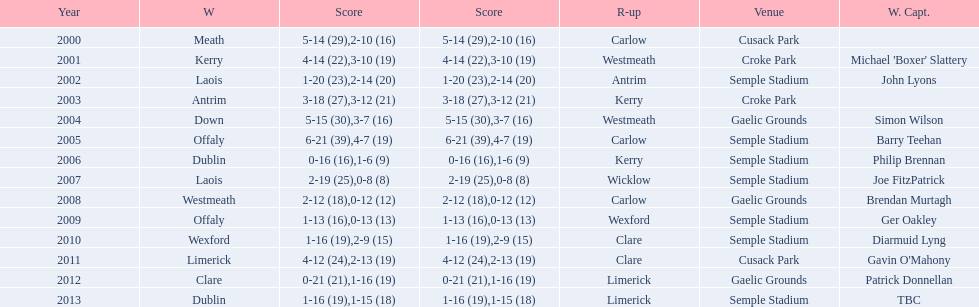Which team secured the title before dublin in 2013? Clare. 